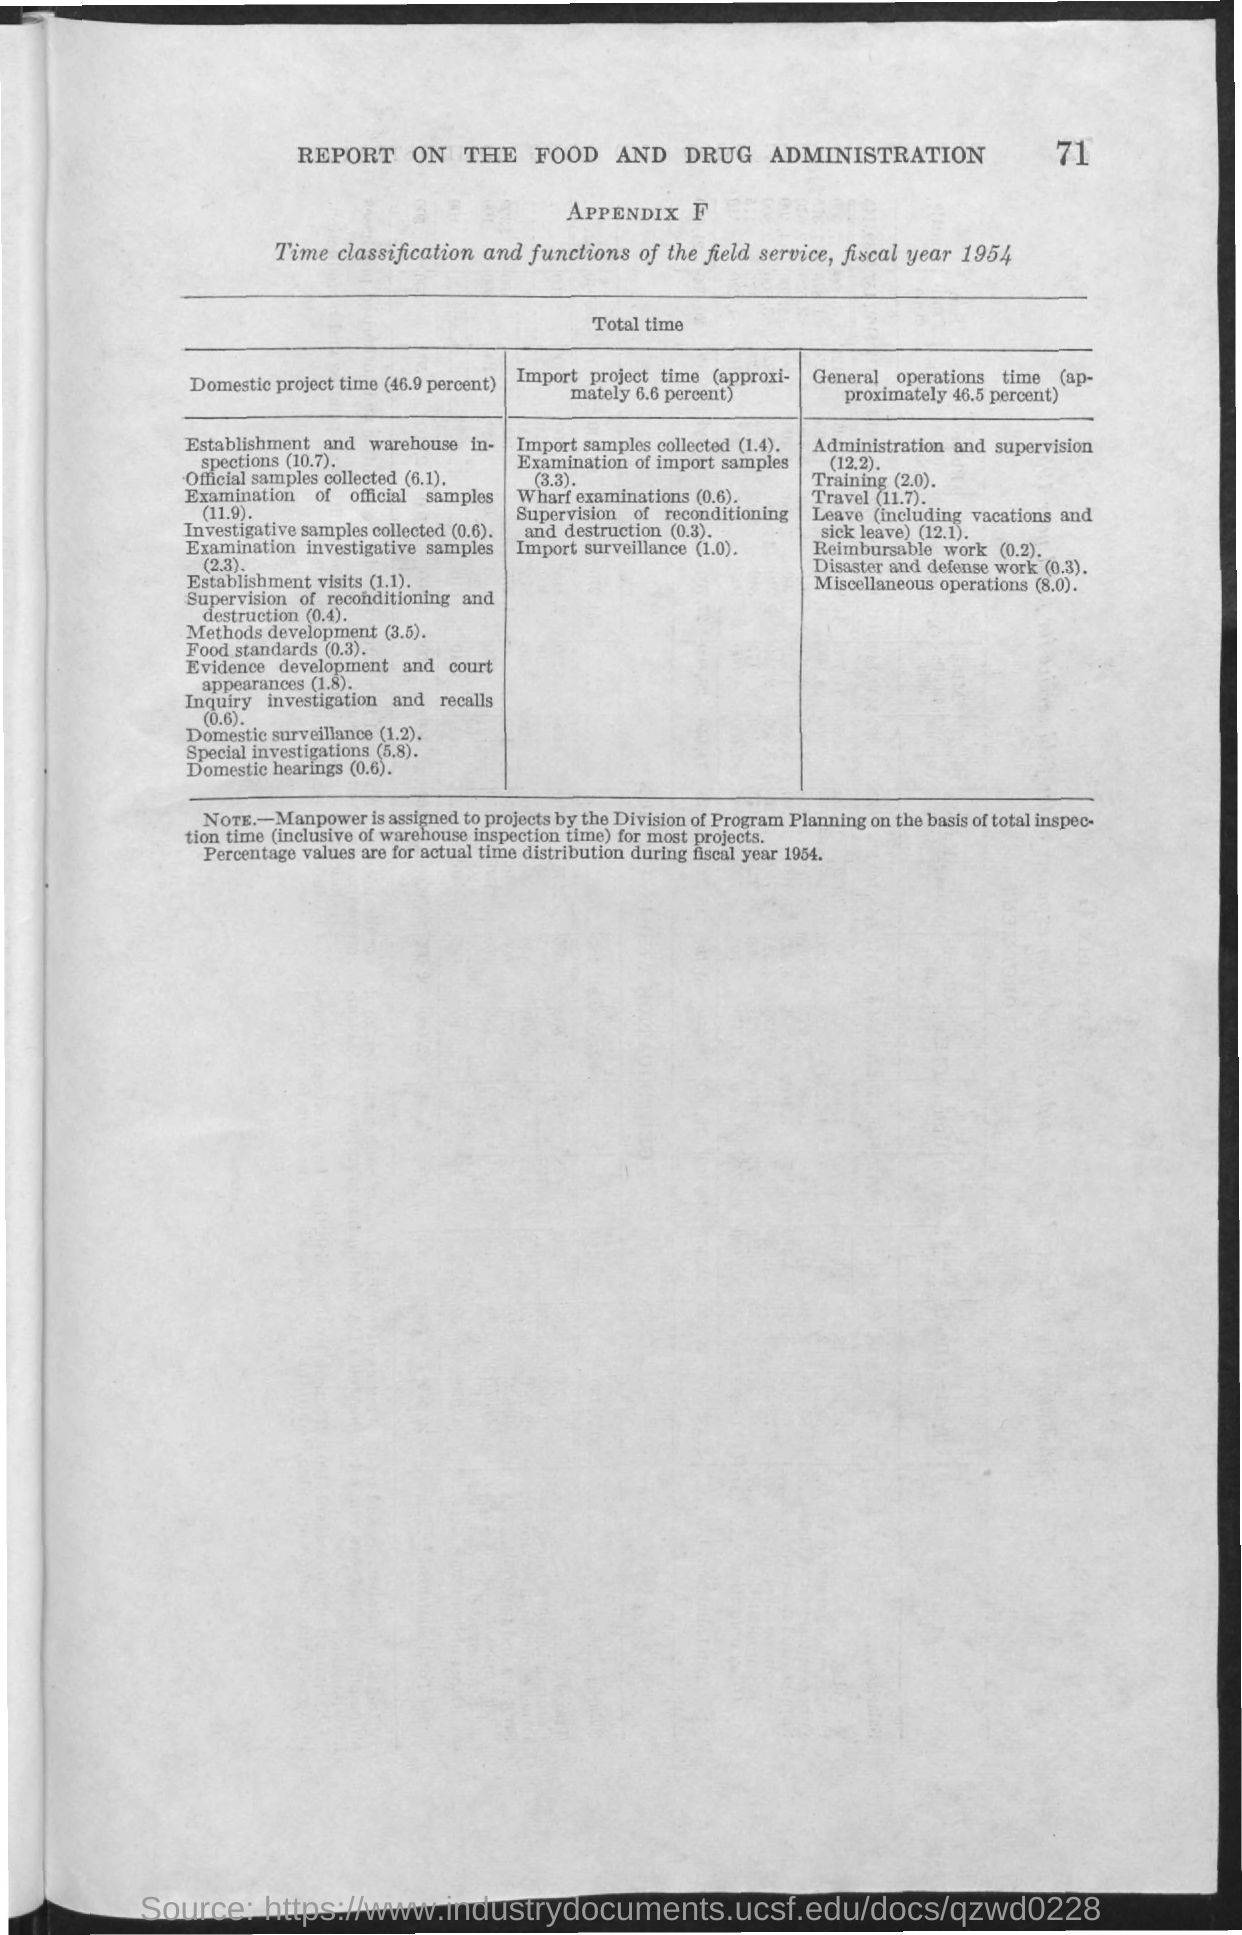Outline some significant characteristics in this image. The estimated time for domestic special investigations is 5.8 hours. The second title in the document is "Appendix F. This document is titled 'Report on the Food and Drug Administration'. The total estimated time for the domestic project is 46.9%. The time required for wharf examinations is 0.6 hours. 